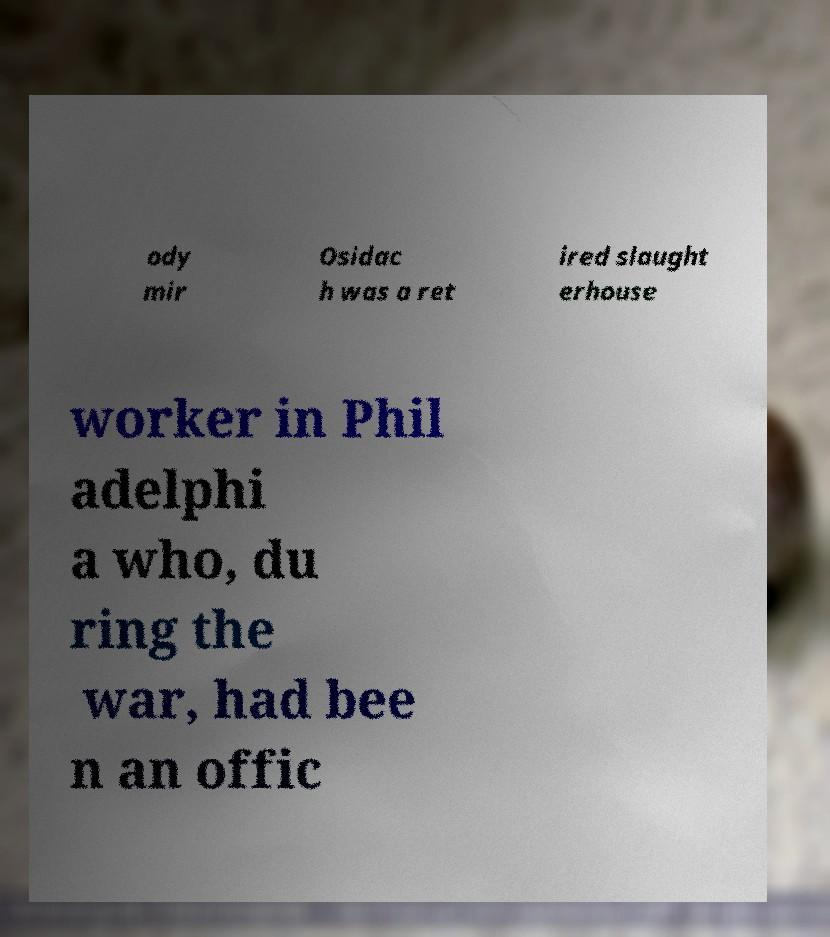Please identify and transcribe the text found in this image. ody mir Osidac h was a ret ired slaught erhouse worker in Phil adelphi a who, du ring the war, had bee n an offic 